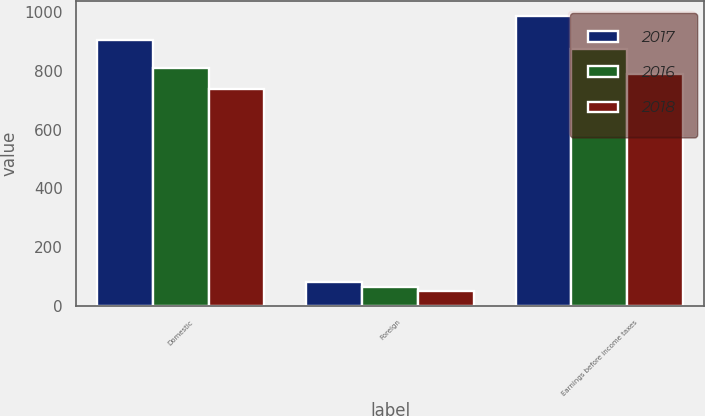<chart> <loc_0><loc_0><loc_500><loc_500><stacked_bar_chart><ecel><fcel>Domestic<fcel>Foreign<fcel>Earnings before income taxes<nl><fcel>2017<fcel>905<fcel>82<fcel>987<nl><fcel>2016<fcel>809.4<fcel>63.7<fcel>873.1<nl><fcel>2018<fcel>739.4<fcel>50.3<fcel>789.7<nl></chart> 